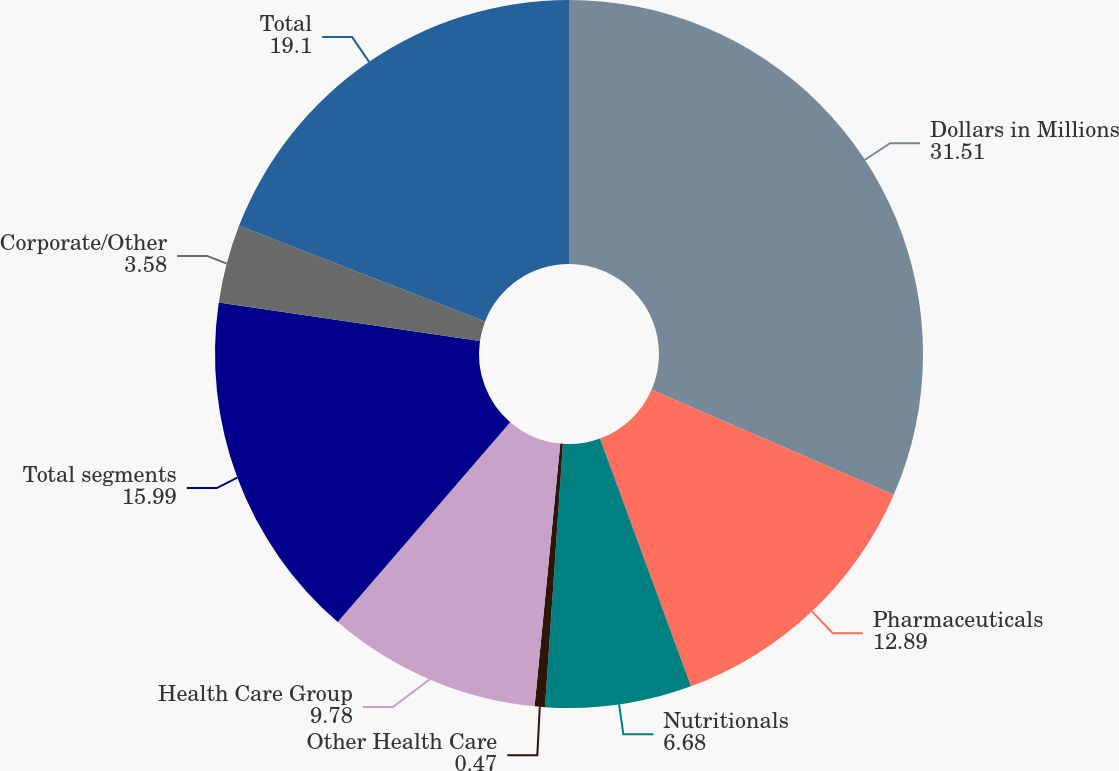<chart> <loc_0><loc_0><loc_500><loc_500><pie_chart><fcel>Dollars in Millions<fcel>Pharmaceuticals<fcel>Nutritionals<fcel>Other Health Care<fcel>Health Care Group<fcel>Total segments<fcel>Corporate/Other<fcel>Total<nl><fcel>31.51%<fcel>12.89%<fcel>6.68%<fcel>0.47%<fcel>9.78%<fcel>15.99%<fcel>3.58%<fcel>19.1%<nl></chart> 